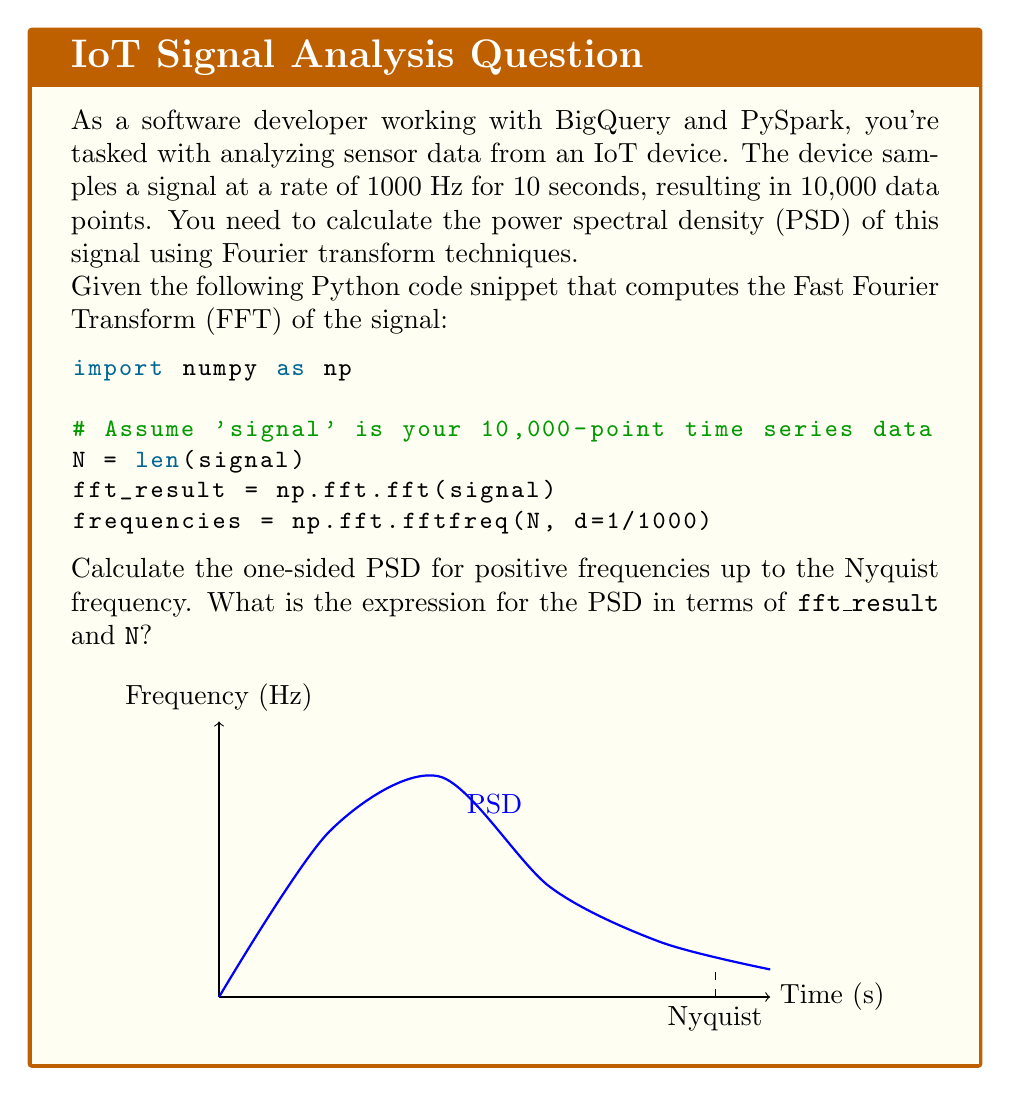Could you help me with this problem? To calculate the one-sided Power Spectral Density (PSD) using the FFT result, we need to follow these steps:

1) The FFT result (`fft_result`) is complex-valued and symmetric. For a real input signal, we only need the positive frequencies up to the Nyquist frequency.

2) The Nyquist frequency is half the sampling rate. In this case, it's 500 Hz (1000 Hz / 2).

3) To get the one-sided PSD, we need to:
   a) Take the magnitude squared of the FFT result
   b) Multiply by 2 to account for the negative frequencies (except for DC and Nyquist components)
   c) Normalize by the square of the total number of samples and the sampling frequency

4) The mathematical expression for the one-sided PSD is:

   $$ PSD = \frac{2 |X(f)|^2}{N^2 f_s} $$

   Where:
   - $X(f)$ is the FFT result
   - $N$ is the number of samples
   - $f_s$ is the sampling frequency

5) In terms of our Python variables:
   - $X(f)$ is `fft_result`
   - $N$ is `N` (which is 10,000)
   - $f_s$ is 1000 Hz

6) Putting this together in Python-like notation, the PSD for positive frequencies up to Nyquist would be:

   ```python
   PSD = 2.0 * np.abs(fft_result[:N//2])**2 / (N**2 * 1000)
   ```

   Note: The factor of 2.0 is applied to all frequencies except DC (index 0) and Nyquist (last index), so in practice you might want to handle these separately.

7) The units of this PSD will be in $\text{signal}^2/\text{Hz}$, where "signal" is the unit of your original time series data.
Answer: $$ PSD = \frac{2 |X(f)|^2}{N^2 f_s} $$ 